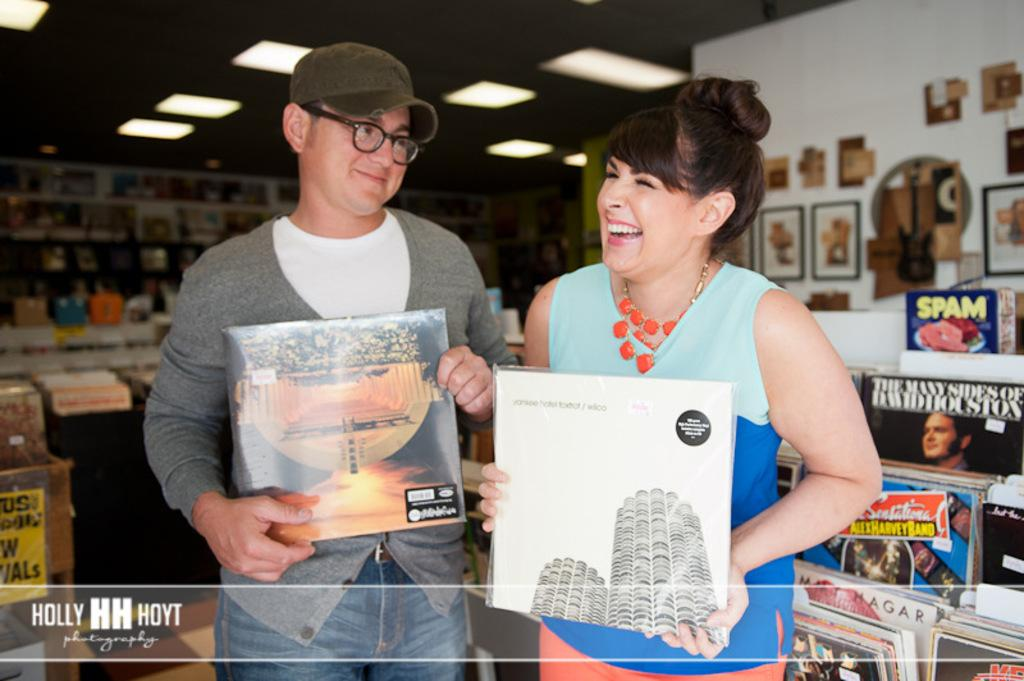How many people are present in the image? There are 2 people standing in the image. What are the people holding in the image? The people are holding books. Can you describe the surroundings in the image? There are books on shelves and photo frames on the walls. What is visible at the top of the image? There are lights at the top of the image. What is the name of the grandmother in the image? There is no grandmother present in the image. What type of beast can be seen in the photo frames on the walls? There are no beasts visible in the photo frames on the walls; they contain images of people or objects. 